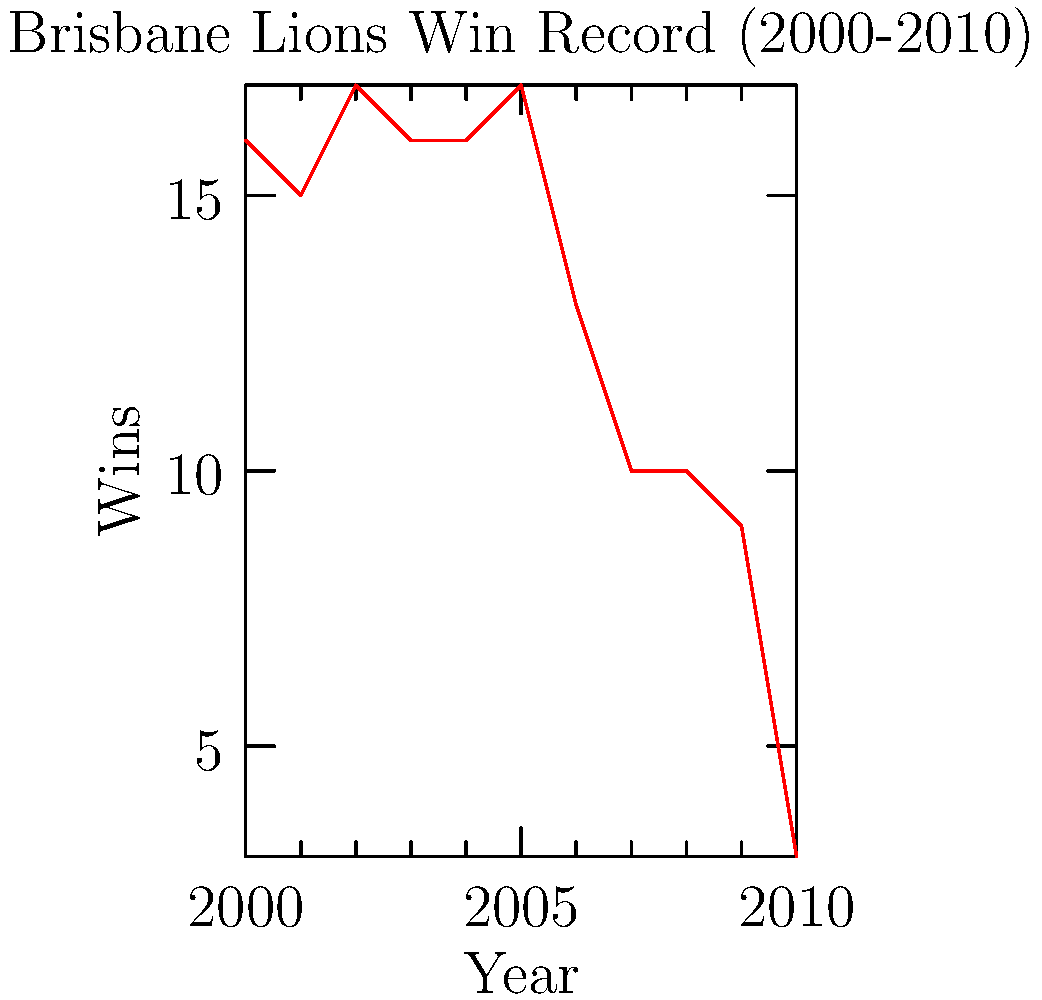Analyzing the graph of the Brisbane Lions' win record from 2000 to 2010, in which year did the team experience their most significant decline in performance compared to the previous year? To determine the year with the most significant decline in performance, we need to analyze the differences in wins between consecutive years:

1. 2000 to 2001: 16 to 15 wins (decrease of 1)
2. 2001 to 2002: 15 to 17 wins (increase)
3. 2002 to 2003: 17 to 16 wins (decrease of 1)
4. 2003 to 2004: 16 to 16 wins (no change)
5. 2004 to 2005: 16 to 17 wins (increase)
6. 2005 to 2006: 17 to 13 wins (decrease of 4)
7. 2006 to 2007: 13 to 10 wins (decrease of 3)
8. 2007 to 2008: 10 to 10 wins (no change)
9. 2008 to 2009: 10 to 9 wins (decrease of 1)
10. 2009 to 2010: 9 to 3 wins (decrease of 6)

The largest decline occurred between 2009 and 2010, with a decrease of 6 wins.
Answer: 2010 